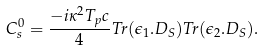Convert formula to latex. <formula><loc_0><loc_0><loc_500><loc_500>C _ { s } ^ { 0 } = \frac { - i \kappa ^ { 2 } T _ { p } c } { 4 } T r ( \epsilon _ { 1 } . D _ { S } ) T r ( \epsilon _ { 2 } . D _ { S } ) .</formula> 